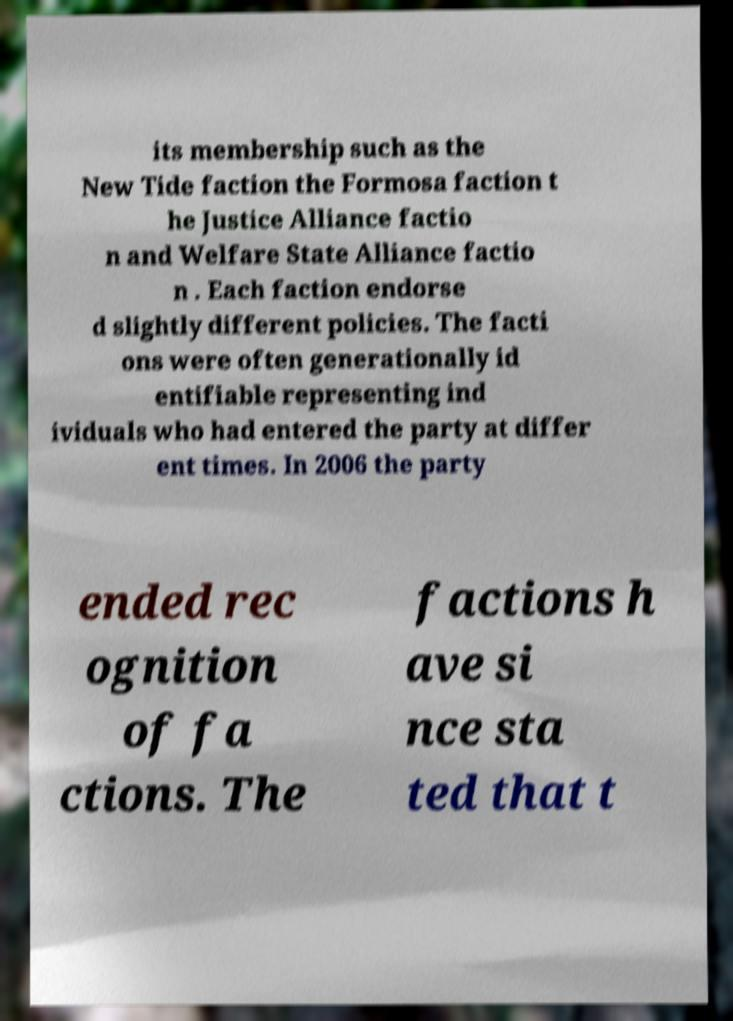For documentation purposes, I need the text within this image transcribed. Could you provide that? its membership such as the New Tide faction the Formosa faction t he Justice Alliance factio n and Welfare State Alliance factio n . Each faction endorse d slightly different policies. The facti ons were often generationally id entifiable representing ind ividuals who had entered the party at differ ent times. In 2006 the party ended rec ognition of fa ctions. The factions h ave si nce sta ted that t 